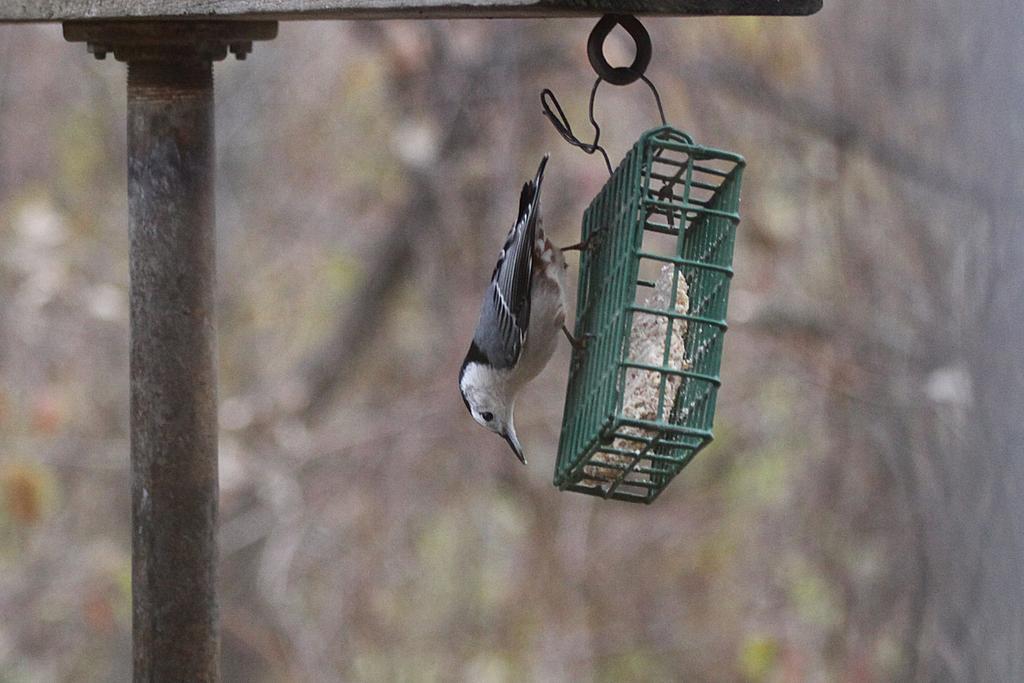Can you describe this image briefly? In this image there is a bird standing on the hanger type of thing which is hanging to the pole. 